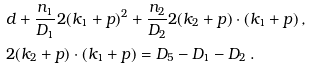Convert formula to latex. <formula><loc_0><loc_0><loc_500><loc_500>& d + \frac { n _ { 1 } } { D _ { 1 } } 2 ( k _ { 1 } + p ) ^ { 2 } + \frac { n _ { 2 } } { D _ { 2 } } 2 ( k _ { 2 } + p ) \cdot ( k _ { 1 } + p ) \, , \\ & 2 ( k _ { 2 } + p ) \cdot ( k _ { 1 } + p ) = D _ { 5 } - D _ { 1 } - D _ { 2 } \, .</formula> 